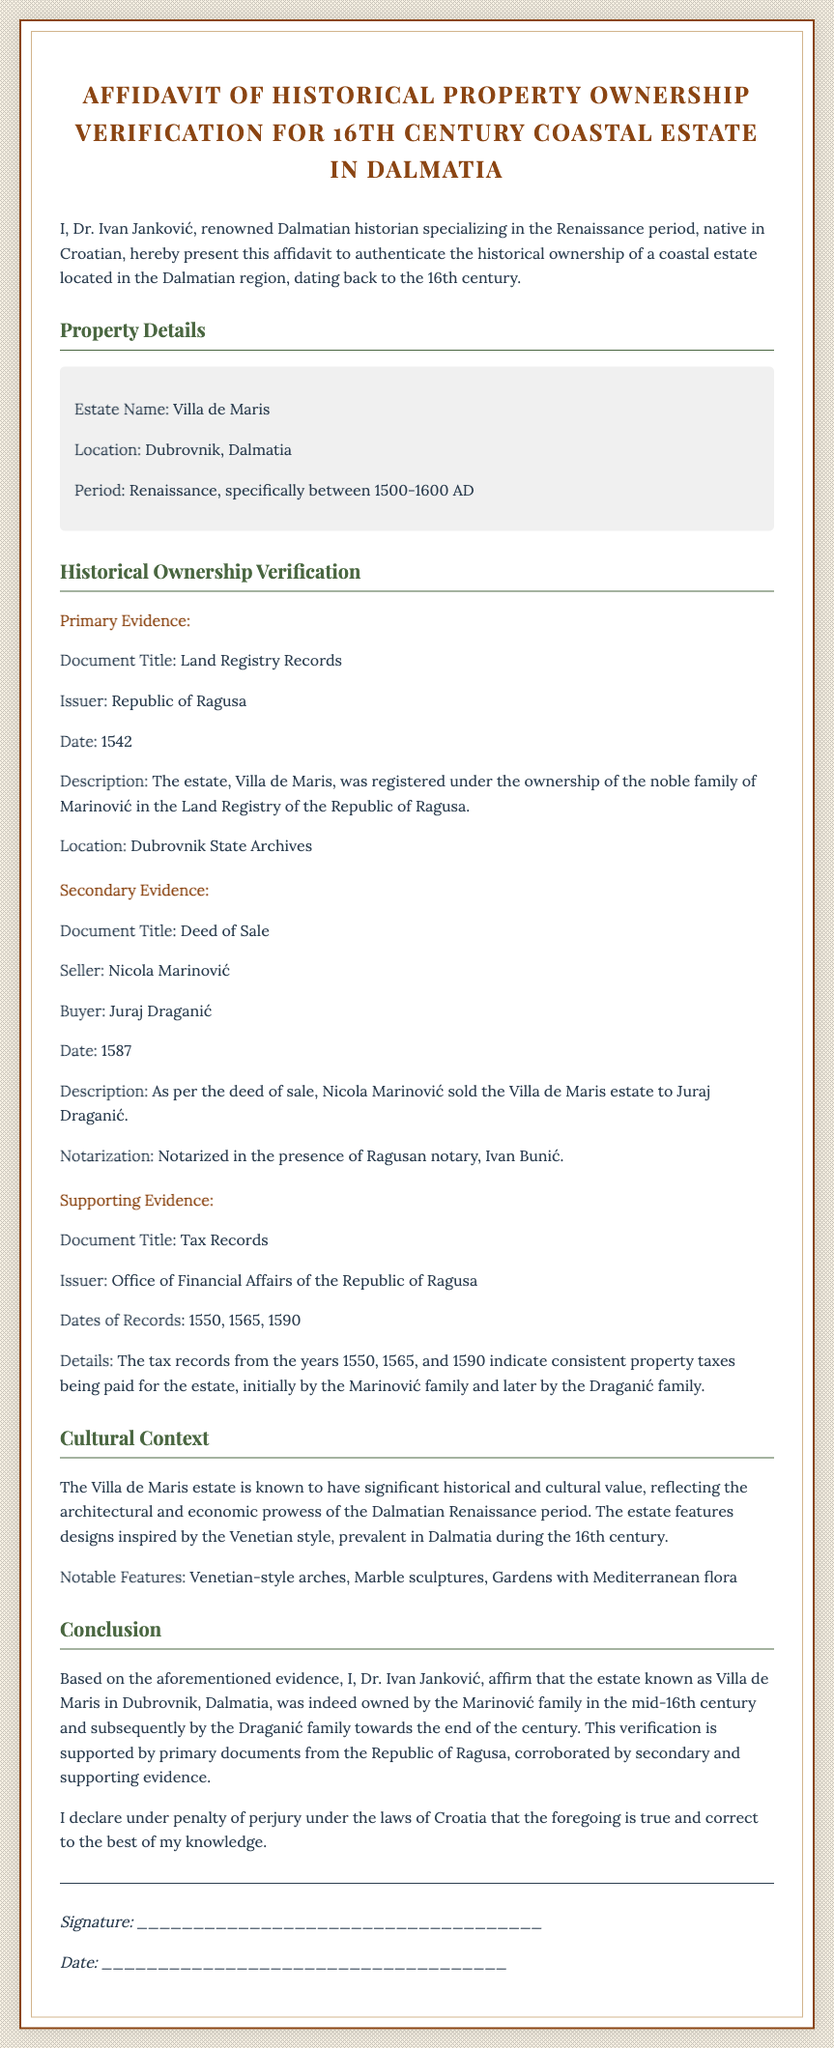What is the name of the estate? The name of the estate can be found in the "Property Details" section, where it is specified.
Answer: Villa de Maris Who issued the Land Registry Records? The issuer of the Land Registry Records is mentioned in the "Primary Evidence" section.
Answer: Republic of Ragusa In what year was the estate registered in the Land Registry? The year of registration is provided in the "Primary Evidence" section under the "Date" heading.
Answer: 1542 What notable feature of the estate is mentioned? Notable features of the estate are listed in the "Cultural Context" section.
Answer: Venetian-style arches Who sold the estate according to the Deed of Sale? The seller's name is mentioned in the "Secondary Evidence" section.
Answer: Nicola Marinović On which date was the Deed of Sale created? The specific date of the Deed of Sale is provided in the "Secondary Evidence" section.
Answer: 1587 What type of evidence supports the property ownership? Different types of evidence are described in the document; this prompts for types explicitly stated.
Answer: Primary, Secondary, Supporting What is the purpose of this affidavit? The purpose of the affidavit is defined in the opening paragraph of the document.
Answer: To authenticate historical ownership Who is the signer of the affidavit? The signer's name is provided at the beginning of the document where the affidavit is introduced.
Answer: Dr. Ivan Janković 